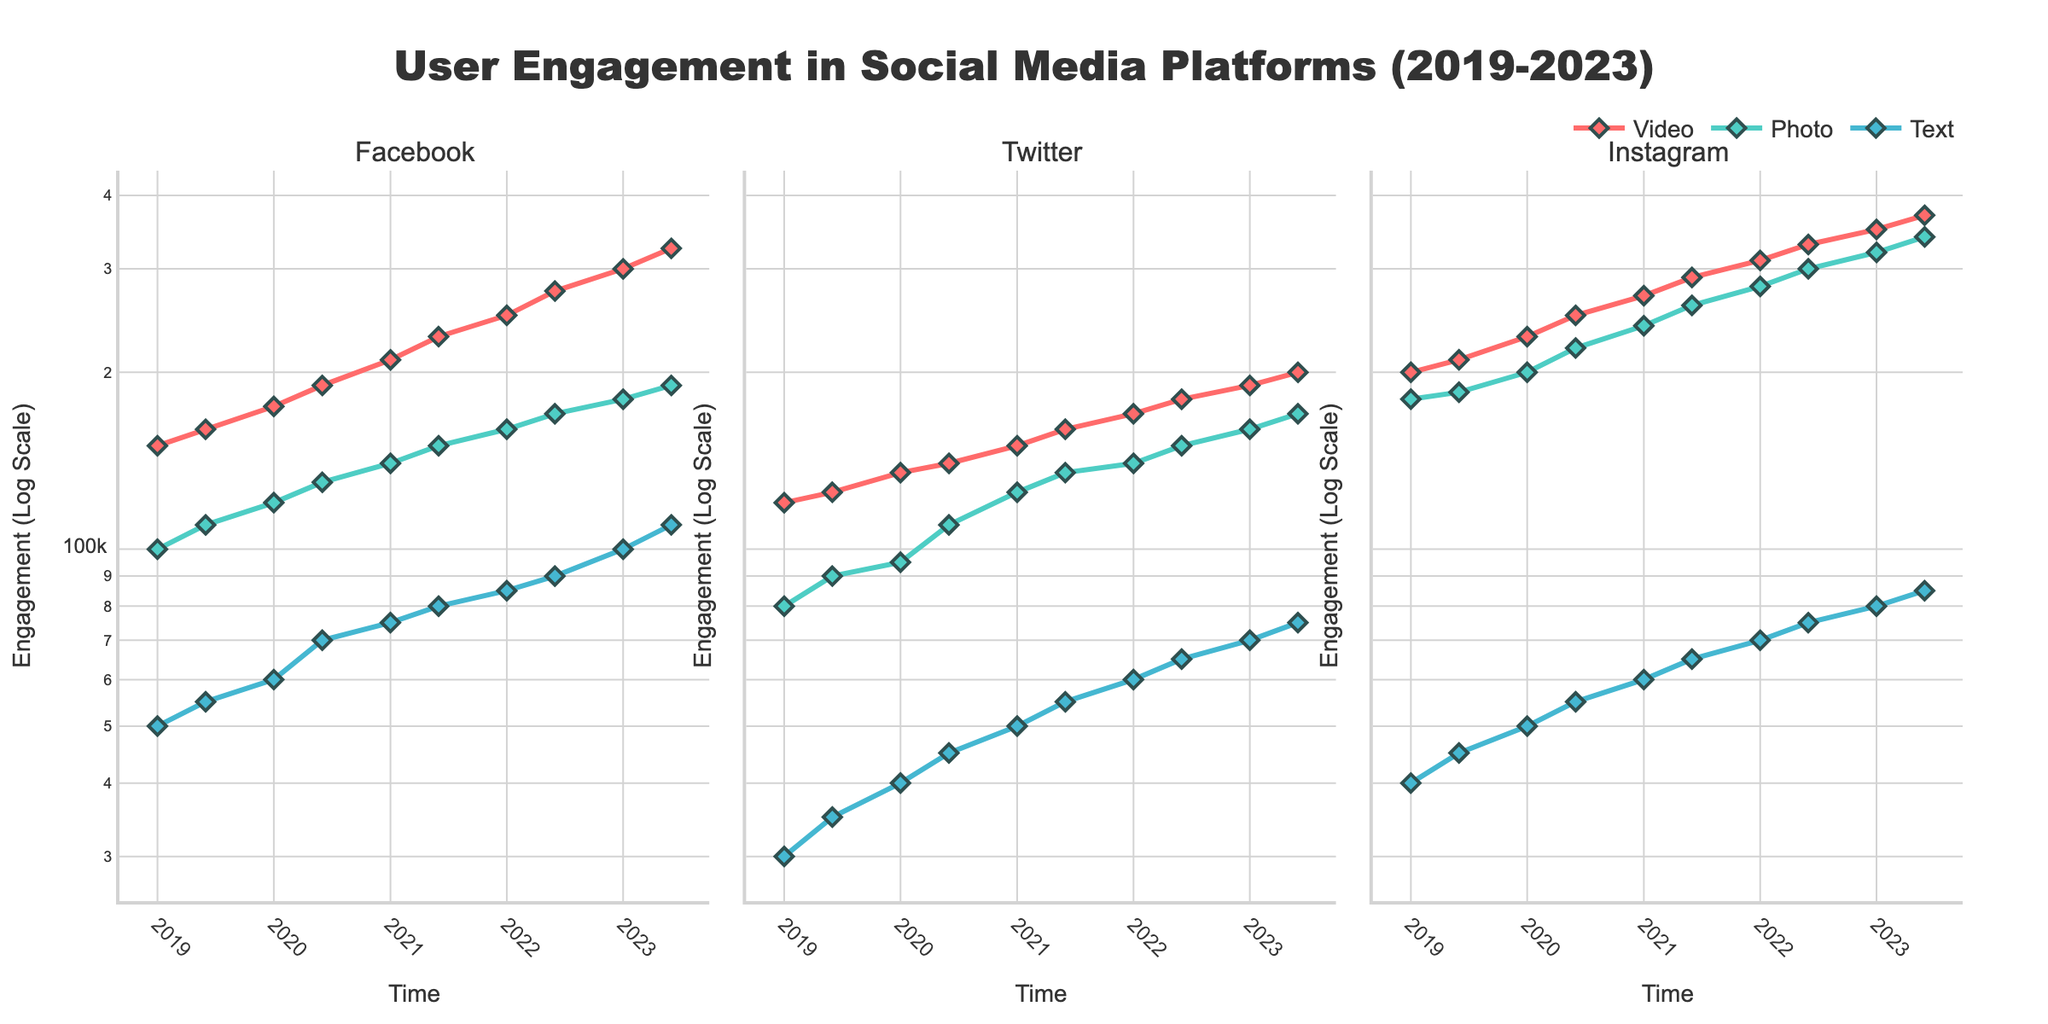Which platform has the highest total user engagement for videos in January 2023? By comparing the engagement values for videos on each platform in January 2023: Facebook (300,000), Twitter (190,000), and Instagram (350,000), Instagram has the highest engagement.
Answer: Instagram What is the general trend of user engagement for photos on Facebook from 2019 to 2023? Observe the data points for photos on Facebook over the given timeframe. The engagement values steadily increase from 100,000 in January 2019 to 190,000 in June 2023.
Answer: Increasing How does user engagement for text content on Twitter in June 2023 compare to January 2023? Check the engagement values for text content on Twitter in January 2023 (70,000) and June 2023 (75,000). Engagement slightly increased from January to June 2023.
Answer: Increased What is the average user engagement for videos across all platforms in January 2020? Sum the engagement values for videos in January 2020 on Facebook (175,000), Twitter (135,000), and Instagram (230,000). The total is 540,000. Divide by 3 to get the average: 540,000 / 3 = 180,000.
Answer: 180,000 Which content type has the largest increase in engagement on Instagram from January 2019 to June 2023? Calculate the increase for each content type: Video (370,000 - 200,000 = 170,000), Photo (340,000 - 180,000 = 160,000), Text (85,000 - 40,000 = 45,000). The largest increase is for Video.
Answer: Video How does the user engagement trend for text content compare between Facebook and Twitter from 2019 to 2023? Observe the engagement values for text content on both platforms. Both show an increasing trend, but Facebook’s increase (50,000 to 110,000) is more significant than Twitter’s (30,000 to 75,000).
Answer: Both increasing; Facebook more significant What month and year did Instagram’s photo engagement surpass 200,000? Look at the engagement for photos on Instagram. The engagement surpasses 200,000 in January 2020.
Answer: January 2020 What's the difference in engagement for video content between Instagram and Facebook in June 2023? Subtract the engagement for videos on Facebook (325,000) from Instagram (370,000): 370,000 - 325,000 = 45,000.
Answer: 45,000 Among the three platforms, which has the least total engagement for text content in June 2023, and what is that value? Compare engagement for text content in June 2023: Facebook (110,000), Twitter (75,000), Instagram (85,000). Twitter has the least: 75,000.
Answer: Twitter; 75,000 